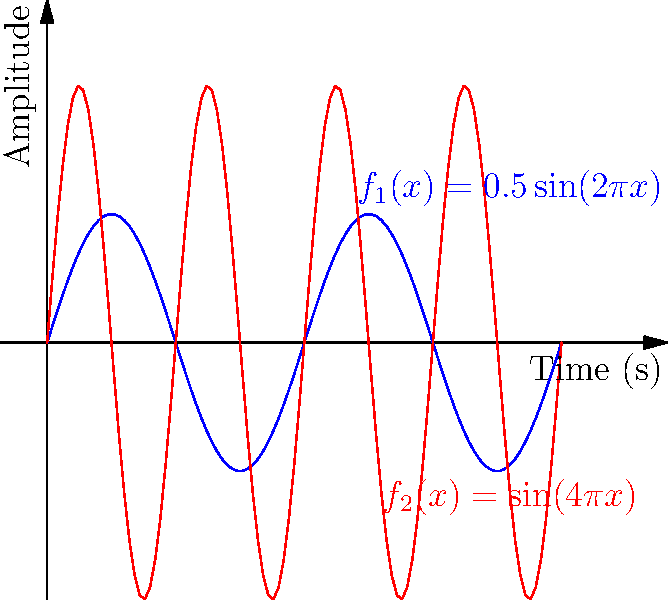As a singer-songwriter influenced by Southern soul music, you're analyzing the frequencies of different instruments. The graph shows two sine curves representing sound waves. The blue curve is given by $f_1(x) = 0.5\sin(2\pi x)$ and the red curve by $f_2(x) = \sin(4\pi x)$. How many times higher is the frequency of the red curve compared to the blue curve? To determine the frequency relationship between the two curves, we need to compare their periods:

1. For a general sine function $f(x) = \sin(bx)$, the period is given by $T = \frac{2\pi}{b}$.

2. For $f_1(x) = 0.5\sin(2\pi x)$:
   $b_1 = 2\pi$
   $T_1 = \frac{2\pi}{2\pi} = 1$

3. For $f_2(x) = \sin(4\pi x)$:
   $b_2 = 4\pi$
   $T_2 = \frac{2\pi}{4\pi} = \frac{1}{2}$

4. The frequency is the reciprocal of the period. So, the frequency ratio is:
   $\frac{f_2}{f_1} = \frac{T_1}{T_2} = \frac{1}{\frac{1}{2}} = 2$

Therefore, the frequency of the red curve is 2 times higher than the blue curve.
Answer: 2 times 